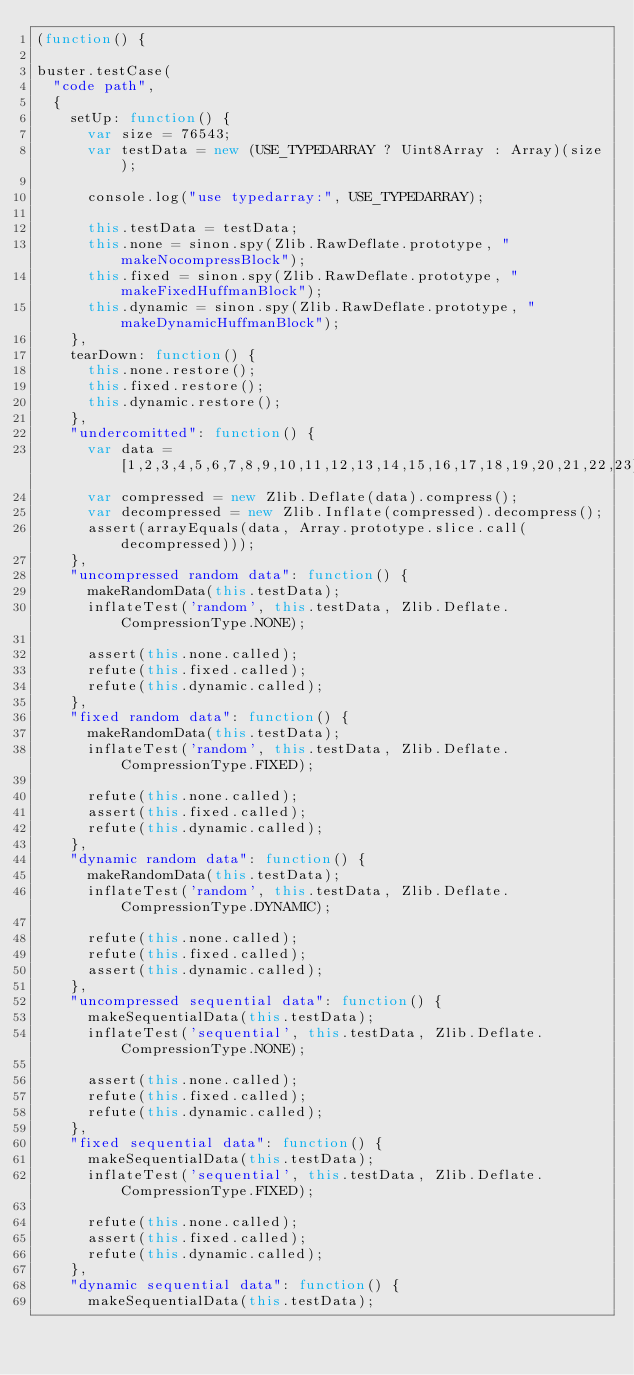Convert code to text. <code><loc_0><loc_0><loc_500><loc_500><_JavaScript_>(function() {

buster.testCase(
  "code path",
  {
    setUp: function() {
      var size = 76543;
      var testData = new (USE_TYPEDARRAY ? Uint8Array : Array)(size);

      console.log("use typedarray:", USE_TYPEDARRAY);

      this.testData = testData;
      this.none = sinon.spy(Zlib.RawDeflate.prototype, "makeNocompressBlock");
      this.fixed = sinon.spy(Zlib.RawDeflate.prototype, "makeFixedHuffmanBlock");
      this.dynamic = sinon.spy(Zlib.RawDeflate.prototype, "makeDynamicHuffmanBlock");
    },
    tearDown: function() {
      this.none.restore();
      this.fixed.restore();
      this.dynamic.restore();
    },
    "undercomitted": function() {
      var data = [1,2,3,4,5,6,7,8,9,10,11,12,13,14,15,16,17,18,19,20,21,22,23];
      var compressed = new Zlib.Deflate(data).compress();
      var decompressed = new Zlib.Inflate(compressed).decompress();
      assert(arrayEquals(data, Array.prototype.slice.call(decompressed)));
    },
    "uncompressed random data": function() {
      makeRandomData(this.testData);
      inflateTest('random', this.testData, Zlib.Deflate.CompressionType.NONE);

      assert(this.none.called);
      refute(this.fixed.called);
      refute(this.dynamic.called);
    },
    "fixed random data": function() {
      makeRandomData(this.testData);
      inflateTest('random', this.testData, Zlib.Deflate.CompressionType.FIXED);

      refute(this.none.called);
      assert(this.fixed.called);
      refute(this.dynamic.called);
    },
    "dynamic random data": function() {
      makeRandomData(this.testData);
      inflateTest('random', this.testData, Zlib.Deflate.CompressionType.DYNAMIC);

      refute(this.none.called);
      refute(this.fixed.called);
      assert(this.dynamic.called);
    },
    "uncompressed sequential data": function() {
      makeSequentialData(this.testData);
      inflateTest('sequential', this.testData, Zlib.Deflate.CompressionType.NONE);

      assert(this.none.called);
      refute(this.fixed.called);
      refute(this.dynamic.called);
    },
    "fixed sequential data": function() {
      makeSequentialData(this.testData);
      inflateTest('sequential', this.testData, Zlib.Deflate.CompressionType.FIXED);

      refute(this.none.called);
      assert(this.fixed.called);
      refute(this.dynamic.called);
    },
    "dynamic sequential data": function() {
      makeSequentialData(this.testData);</code> 